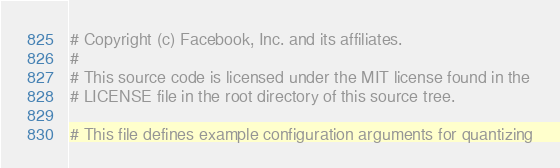Convert code to text. <code><loc_0><loc_0><loc_500><loc_500><_YAML_># Copyright (c) Facebook, Inc. and its affiliates.
#
# This source code is licensed under the MIT license found in the
# LICENSE file in the root directory of this source tree.

# This file defines example configuration arguments for quantizing</code> 